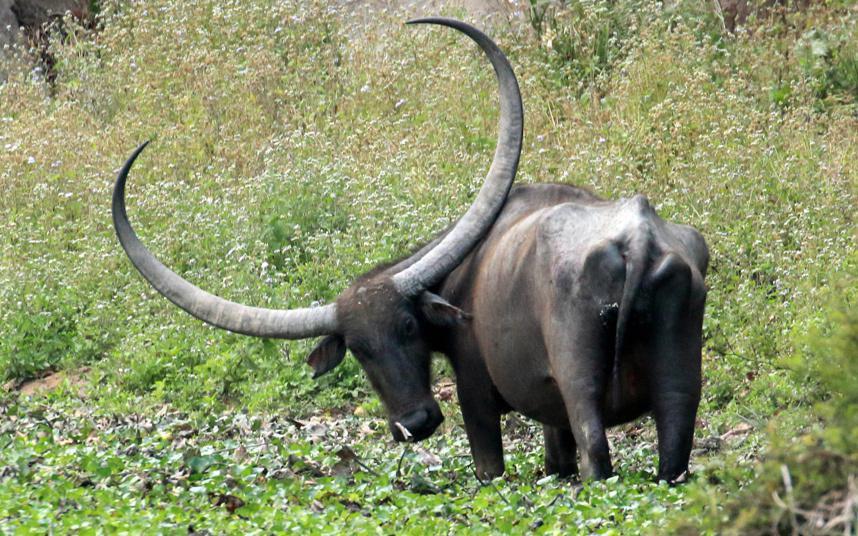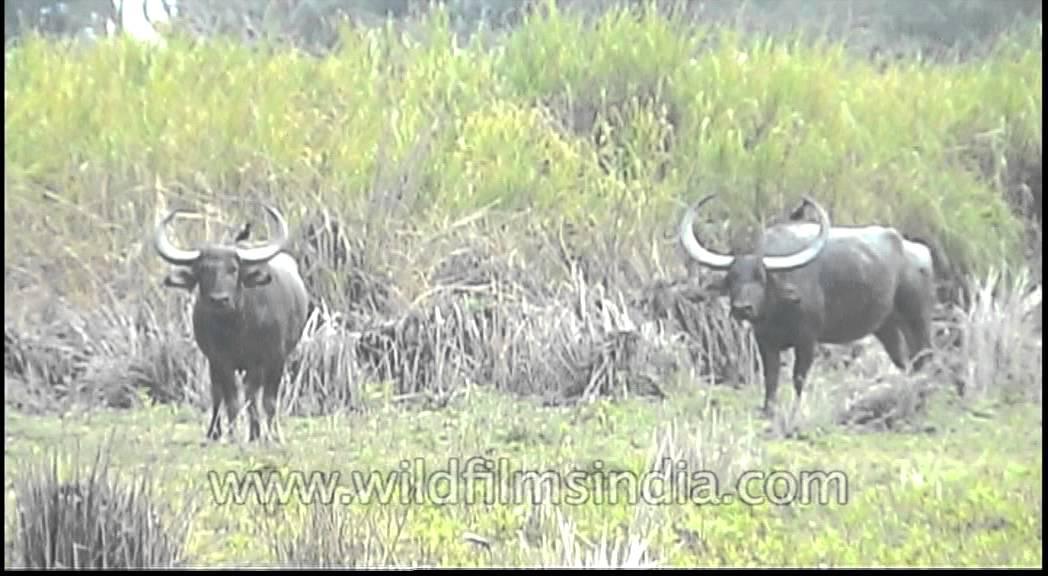The first image is the image on the left, the second image is the image on the right. Given the left and right images, does the statement "There are 3 water buffalos shown." hold true? Answer yes or no. Yes. 